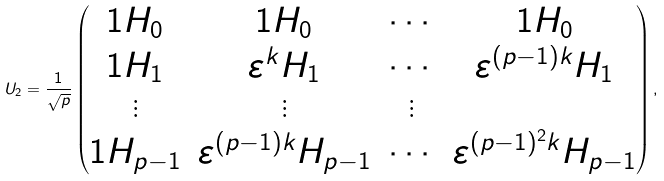Convert formula to latex. <formula><loc_0><loc_0><loc_500><loc_500>U _ { 2 } = \frac { 1 } { \sqrt { p } } \begin{pmatrix} { 1 H _ { 0 } } & { 1 H _ { 0 } } & \cdots & { 1 H _ { 0 } } \\ { 1 H _ { 1 } } & { \varepsilon ^ { k } H _ { 1 } } & \cdots & { \varepsilon ^ { ( p - 1 ) k } H _ { 1 } } \\ \vdots & \vdots & \vdots \\ { 1 H _ { p - 1 } } & { \varepsilon ^ { ( p - 1 ) k } H _ { p - 1 } } & \cdots & { \varepsilon ^ { ( p - 1 ) ^ { 2 } k } H _ { p - 1 } } \end{pmatrix} ,</formula> 